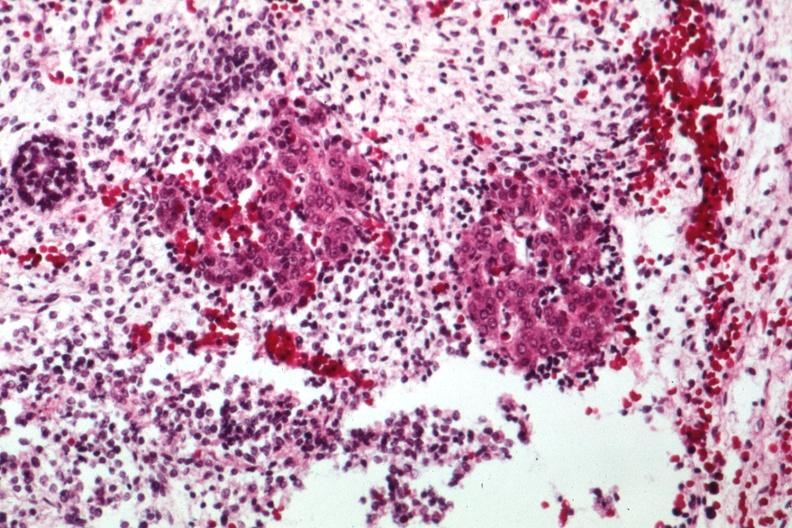does carcinomatosis endometrium primary show acinar tissue looking like pancreas with primitive stroma?
Answer the question using a single word or phrase. No 